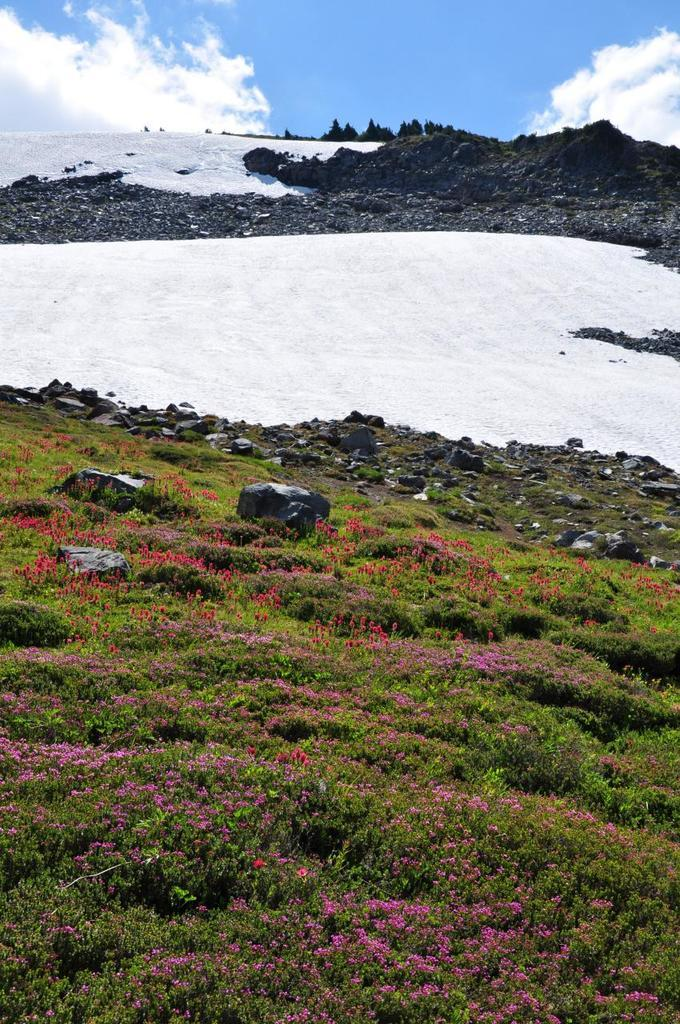What type of plants can be seen in the image? There are plants with flowers in the image. What other natural elements are present in the image? There are rocks and trees in the image. What geographical feature can be seen in the distance? There are snowy mountains in the image. What is visible in the background of the image? The sky is visible in the background of the image. What type of yam is being used as a decoration in the image? There is no yam present in the image; it features plants with flowers, rocks, trees, snowy mountains, and a visible sky. 